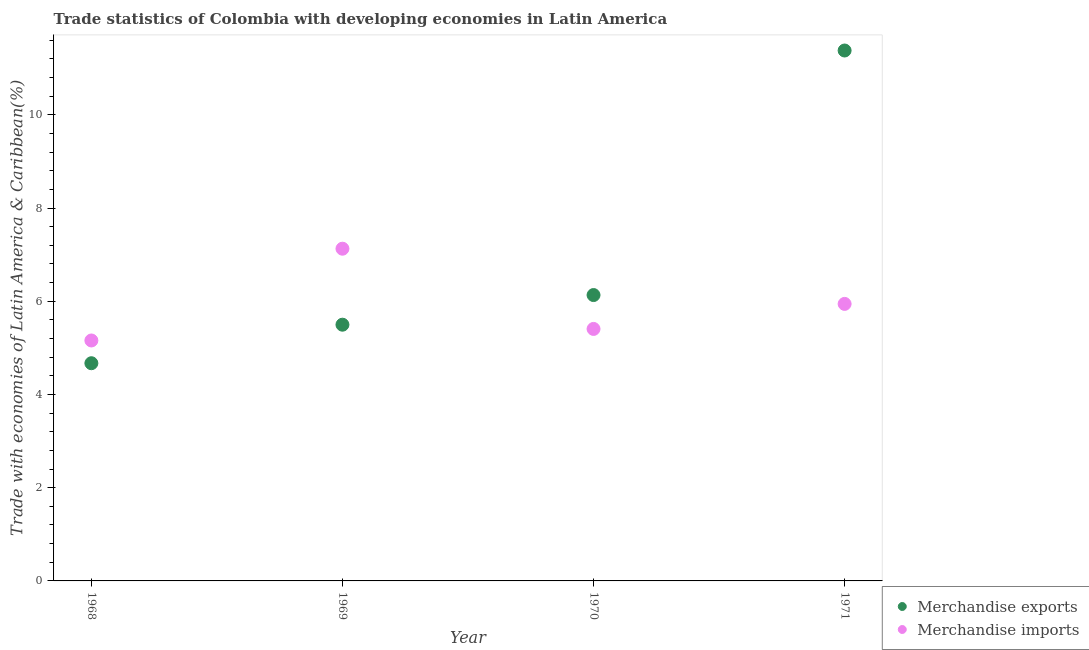What is the merchandise exports in 1970?
Provide a succinct answer. 6.13. Across all years, what is the maximum merchandise imports?
Offer a very short reply. 7.13. Across all years, what is the minimum merchandise exports?
Your response must be concise. 4.67. In which year was the merchandise exports minimum?
Provide a short and direct response. 1968. What is the total merchandise exports in the graph?
Provide a short and direct response. 27.68. What is the difference between the merchandise imports in 1969 and that in 1970?
Provide a short and direct response. 1.72. What is the difference between the merchandise exports in 1968 and the merchandise imports in 1970?
Make the answer very short. -0.74. What is the average merchandise exports per year?
Keep it short and to the point. 6.92. In the year 1968, what is the difference between the merchandise exports and merchandise imports?
Provide a short and direct response. -0.49. What is the ratio of the merchandise imports in 1969 to that in 1971?
Your response must be concise. 1.2. Is the merchandise exports in 1970 less than that in 1971?
Offer a very short reply. Yes. Is the difference between the merchandise exports in 1968 and 1971 greater than the difference between the merchandise imports in 1968 and 1971?
Keep it short and to the point. No. What is the difference between the highest and the second highest merchandise exports?
Provide a short and direct response. 5.25. What is the difference between the highest and the lowest merchandise exports?
Your response must be concise. 6.71. In how many years, is the merchandise exports greater than the average merchandise exports taken over all years?
Offer a very short reply. 1. Is the merchandise imports strictly greater than the merchandise exports over the years?
Provide a succinct answer. No. What is the difference between two consecutive major ticks on the Y-axis?
Your answer should be very brief. 2. Are the values on the major ticks of Y-axis written in scientific E-notation?
Offer a very short reply. No. Does the graph contain any zero values?
Give a very brief answer. No. Does the graph contain grids?
Offer a very short reply. No. Where does the legend appear in the graph?
Provide a short and direct response. Bottom right. How many legend labels are there?
Keep it short and to the point. 2. What is the title of the graph?
Give a very brief answer. Trade statistics of Colombia with developing economies in Latin America. What is the label or title of the X-axis?
Your response must be concise. Year. What is the label or title of the Y-axis?
Give a very brief answer. Trade with economies of Latin America & Caribbean(%). What is the Trade with economies of Latin America & Caribbean(%) in Merchandise exports in 1968?
Provide a succinct answer. 4.67. What is the Trade with economies of Latin America & Caribbean(%) in Merchandise imports in 1968?
Keep it short and to the point. 5.16. What is the Trade with economies of Latin America & Caribbean(%) in Merchandise exports in 1969?
Give a very brief answer. 5.5. What is the Trade with economies of Latin America & Caribbean(%) in Merchandise imports in 1969?
Provide a succinct answer. 7.13. What is the Trade with economies of Latin America & Caribbean(%) in Merchandise exports in 1970?
Your answer should be compact. 6.13. What is the Trade with economies of Latin America & Caribbean(%) of Merchandise imports in 1970?
Your answer should be very brief. 5.41. What is the Trade with economies of Latin America & Caribbean(%) in Merchandise exports in 1971?
Provide a succinct answer. 11.38. What is the Trade with economies of Latin America & Caribbean(%) of Merchandise imports in 1971?
Your response must be concise. 5.94. Across all years, what is the maximum Trade with economies of Latin America & Caribbean(%) in Merchandise exports?
Your response must be concise. 11.38. Across all years, what is the maximum Trade with economies of Latin America & Caribbean(%) of Merchandise imports?
Make the answer very short. 7.13. Across all years, what is the minimum Trade with economies of Latin America & Caribbean(%) of Merchandise exports?
Your response must be concise. 4.67. Across all years, what is the minimum Trade with economies of Latin America & Caribbean(%) of Merchandise imports?
Your answer should be very brief. 5.16. What is the total Trade with economies of Latin America & Caribbean(%) of Merchandise exports in the graph?
Your answer should be compact. 27.68. What is the total Trade with economies of Latin America & Caribbean(%) in Merchandise imports in the graph?
Ensure brevity in your answer.  23.64. What is the difference between the Trade with economies of Latin America & Caribbean(%) of Merchandise exports in 1968 and that in 1969?
Keep it short and to the point. -0.83. What is the difference between the Trade with economies of Latin America & Caribbean(%) of Merchandise imports in 1968 and that in 1969?
Give a very brief answer. -1.97. What is the difference between the Trade with economies of Latin America & Caribbean(%) in Merchandise exports in 1968 and that in 1970?
Your answer should be compact. -1.46. What is the difference between the Trade with economies of Latin America & Caribbean(%) in Merchandise imports in 1968 and that in 1970?
Make the answer very short. -0.25. What is the difference between the Trade with economies of Latin America & Caribbean(%) in Merchandise exports in 1968 and that in 1971?
Give a very brief answer. -6.71. What is the difference between the Trade with economies of Latin America & Caribbean(%) in Merchandise imports in 1968 and that in 1971?
Your response must be concise. -0.78. What is the difference between the Trade with economies of Latin America & Caribbean(%) of Merchandise exports in 1969 and that in 1970?
Provide a short and direct response. -0.64. What is the difference between the Trade with economies of Latin America & Caribbean(%) of Merchandise imports in 1969 and that in 1970?
Provide a short and direct response. 1.72. What is the difference between the Trade with economies of Latin America & Caribbean(%) in Merchandise exports in 1969 and that in 1971?
Ensure brevity in your answer.  -5.88. What is the difference between the Trade with economies of Latin America & Caribbean(%) of Merchandise imports in 1969 and that in 1971?
Your answer should be very brief. 1.18. What is the difference between the Trade with economies of Latin America & Caribbean(%) of Merchandise exports in 1970 and that in 1971?
Your response must be concise. -5.25. What is the difference between the Trade with economies of Latin America & Caribbean(%) of Merchandise imports in 1970 and that in 1971?
Keep it short and to the point. -0.54. What is the difference between the Trade with economies of Latin America & Caribbean(%) in Merchandise exports in 1968 and the Trade with economies of Latin America & Caribbean(%) in Merchandise imports in 1969?
Offer a very short reply. -2.46. What is the difference between the Trade with economies of Latin America & Caribbean(%) in Merchandise exports in 1968 and the Trade with economies of Latin America & Caribbean(%) in Merchandise imports in 1970?
Your response must be concise. -0.74. What is the difference between the Trade with economies of Latin America & Caribbean(%) in Merchandise exports in 1968 and the Trade with economies of Latin America & Caribbean(%) in Merchandise imports in 1971?
Your answer should be compact. -1.27. What is the difference between the Trade with economies of Latin America & Caribbean(%) of Merchandise exports in 1969 and the Trade with economies of Latin America & Caribbean(%) of Merchandise imports in 1970?
Give a very brief answer. 0.09. What is the difference between the Trade with economies of Latin America & Caribbean(%) in Merchandise exports in 1969 and the Trade with economies of Latin America & Caribbean(%) in Merchandise imports in 1971?
Make the answer very short. -0.45. What is the difference between the Trade with economies of Latin America & Caribbean(%) in Merchandise exports in 1970 and the Trade with economies of Latin America & Caribbean(%) in Merchandise imports in 1971?
Ensure brevity in your answer.  0.19. What is the average Trade with economies of Latin America & Caribbean(%) of Merchandise exports per year?
Offer a terse response. 6.92. What is the average Trade with economies of Latin America & Caribbean(%) of Merchandise imports per year?
Provide a short and direct response. 5.91. In the year 1968, what is the difference between the Trade with economies of Latin America & Caribbean(%) of Merchandise exports and Trade with economies of Latin America & Caribbean(%) of Merchandise imports?
Make the answer very short. -0.49. In the year 1969, what is the difference between the Trade with economies of Latin America & Caribbean(%) of Merchandise exports and Trade with economies of Latin America & Caribbean(%) of Merchandise imports?
Keep it short and to the point. -1.63. In the year 1970, what is the difference between the Trade with economies of Latin America & Caribbean(%) in Merchandise exports and Trade with economies of Latin America & Caribbean(%) in Merchandise imports?
Give a very brief answer. 0.73. In the year 1971, what is the difference between the Trade with economies of Latin America & Caribbean(%) of Merchandise exports and Trade with economies of Latin America & Caribbean(%) of Merchandise imports?
Offer a very short reply. 5.44. What is the ratio of the Trade with economies of Latin America & Caribbean(%) in Merchandise exports in 1968 to that in 1969?
Your answer should be compact. 0.85. What is the ratio of the Trade with economies of Latin America & Caribbean(%) in Merchandise imports in 1968 to that in 1969?
Provide a succinct answer. 0.72. What is the ratio of the Trade with economies of Latin America & Caribbean(%) of Merchandise exports in 1968 to that in 1970?
Provide a succinct answer. 0.76. What is the ratio of the Trade with economies of Latin America & Caribbean(%) in Merchandise imports in 1968 to that in 1970?
Offer a terse response. 0.95. What is the ratio of the Trade with economies of Latin America & Caribbean(%) of Merchandise exports in 1968 to that in 1971?
Provide a succinct answer. 0.41. What is the ratio of the Trade with economies of Latin America & Caribbean(%) of Merchandise imports in 1968 to that in 1971?
Offer a very short reply. 0.87. What is the ratio of the Trade with economies of Latin America & Caribbean(%) in Merchandise exports in 1969 to that in 1970?
Keep it short and to the point. 0.9. What is the ratio of the Trade with economies of Latin America & Caribbean(%) of Merchandise imports in 1969 to that in 1970?
Ensure brevity in your answer.  1.32. What is the ratio of the Trade with economies of Latin America & Caribbean(%) in Merchandise exports in 1969 to that in 1971?
Your response must be concise. 0.48. What is the ratio of the Trade with economies of Latin America & Caribbean(%) in Merchandise imports in 1969 to that in 1971?
Your response must be concise. 1.2. What is the ratio of the Trade with economies of Latin America & Caribbean(%) of Merchandise exports in 1970 to that in 1971?
Keep it short and to the point. 0.54. What is the ratio of the Trade with economies of Latin America & Caribbean(%) of Merchandise imports in 1970 to that in 1971?
Your answer should be very brief. 0.91. What is the difference between the highest and the second highest Trade with economies of Latin America & Caribbean(%) in Merchandise exports?
Your answer should be very brief. 5.25. What is the difference between the highest and the second highest Trade with economies of Latin America & Caribbean(%) of Merchandise imports?
Provide a short and direct response. 1.18. What is the difference between the highest and the lowest Trade with economies of Latin America & Caribbean(%) of Merchandise exports?
Provide a succinct answer. 6.71. What is the difference between the highest and the lowest Trade with economies of Latin America & Caribbean(%) of Merchandise imports?
Your response must be concise. 1.97. 